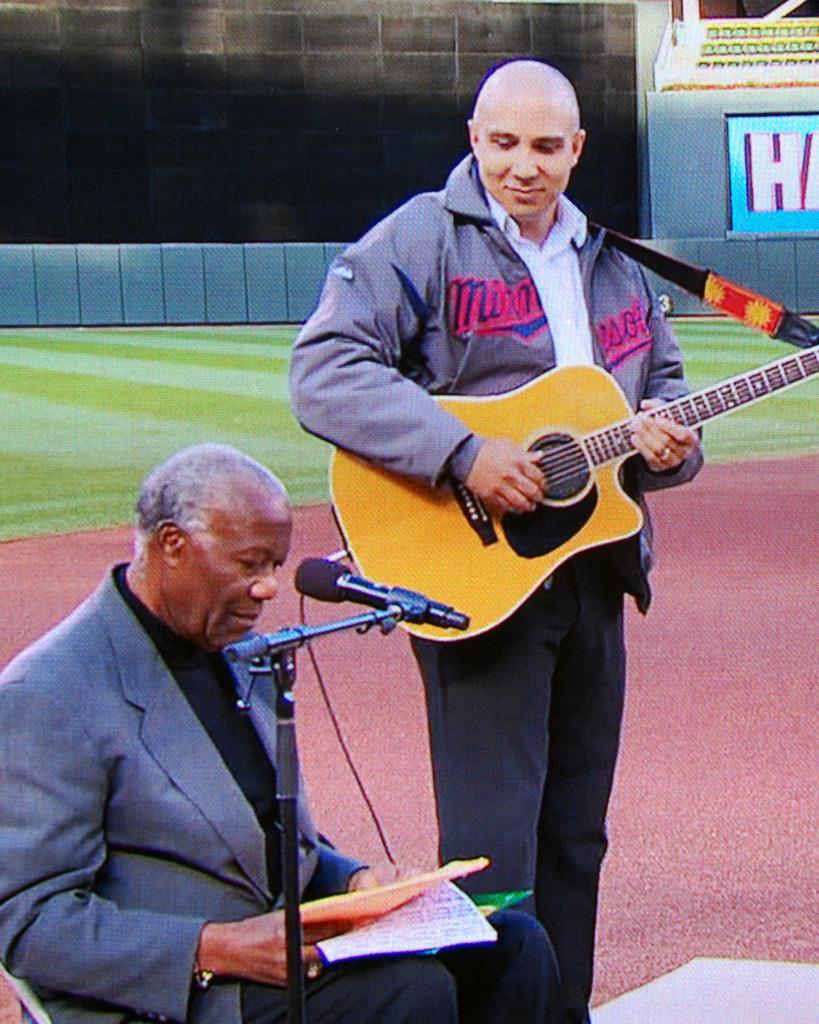In one or two sentences, can you explain what this image depicts? This man wore jacket and playing guitar. This man is sitting on a chair wore suit and holding papers. In-front of this man there is a mic with holder. At background there is a grass. 